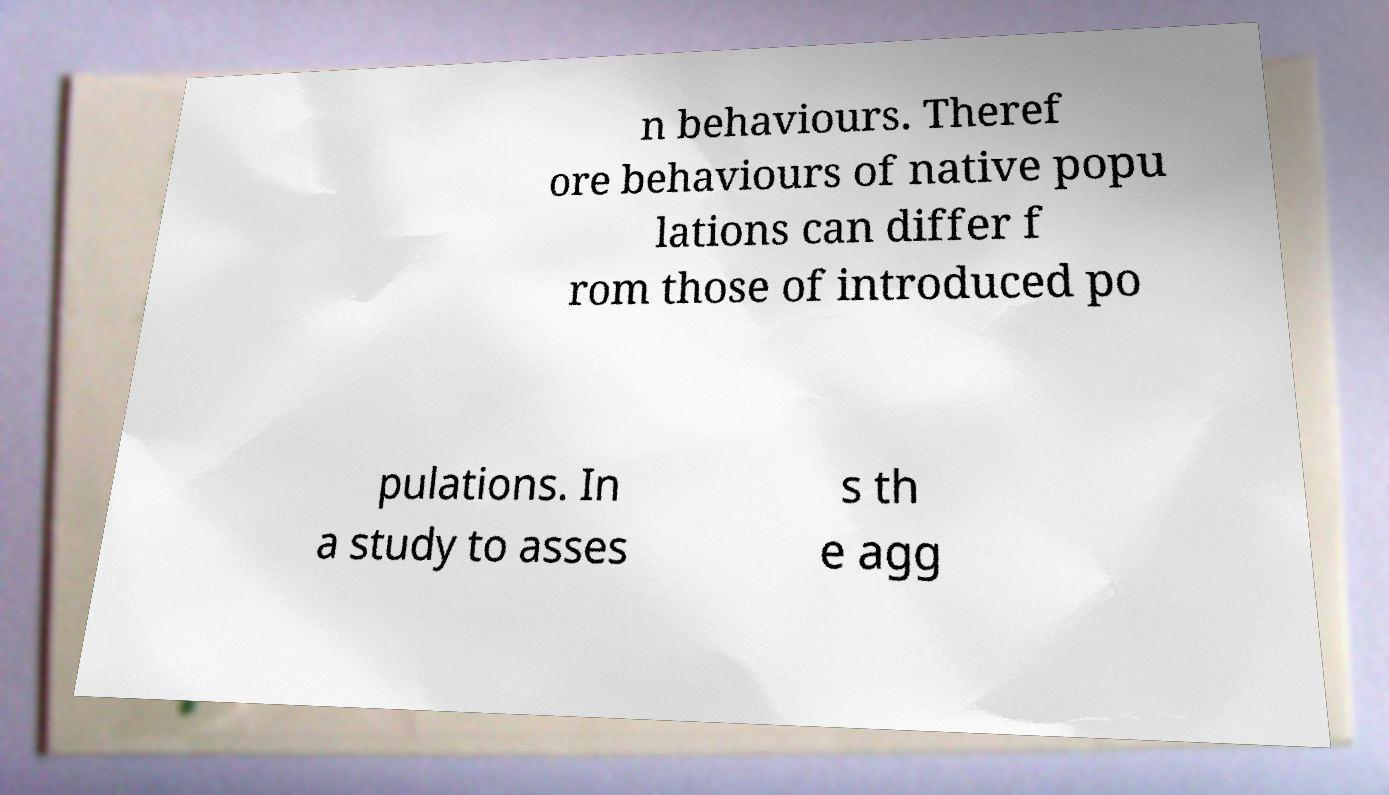Could you assist in decoding the text presented in this image and type it out clearly? n behaviours. Theref ore behaviours of native popu lations can differ f rom those of introduced po pulations. In a study to asses s th e agg 